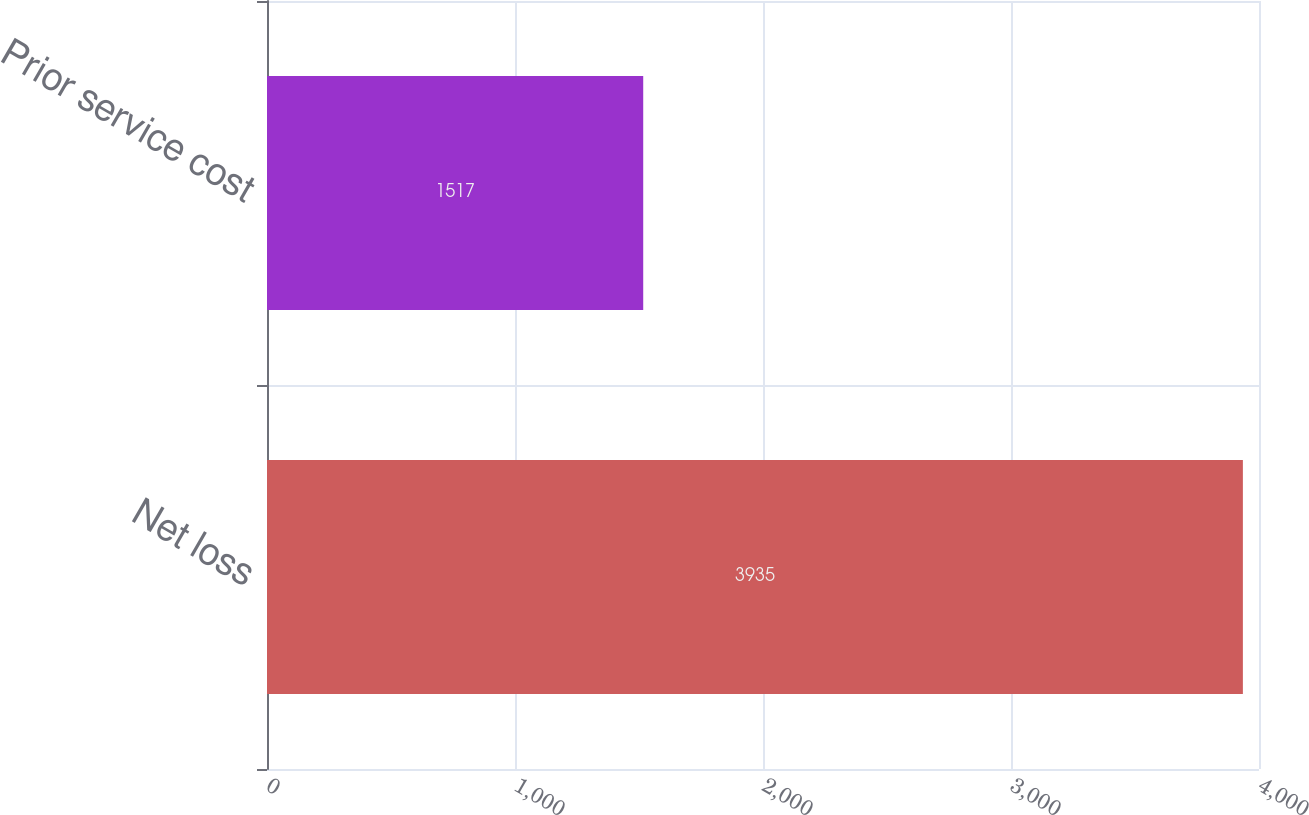<chart> <loc_0><loc_0><loc_500><loc_500><bar_chart><fcel>Net loss<fcel>Prior service cost<nl><fcel>3935<fcel>1517<nl></chart> 